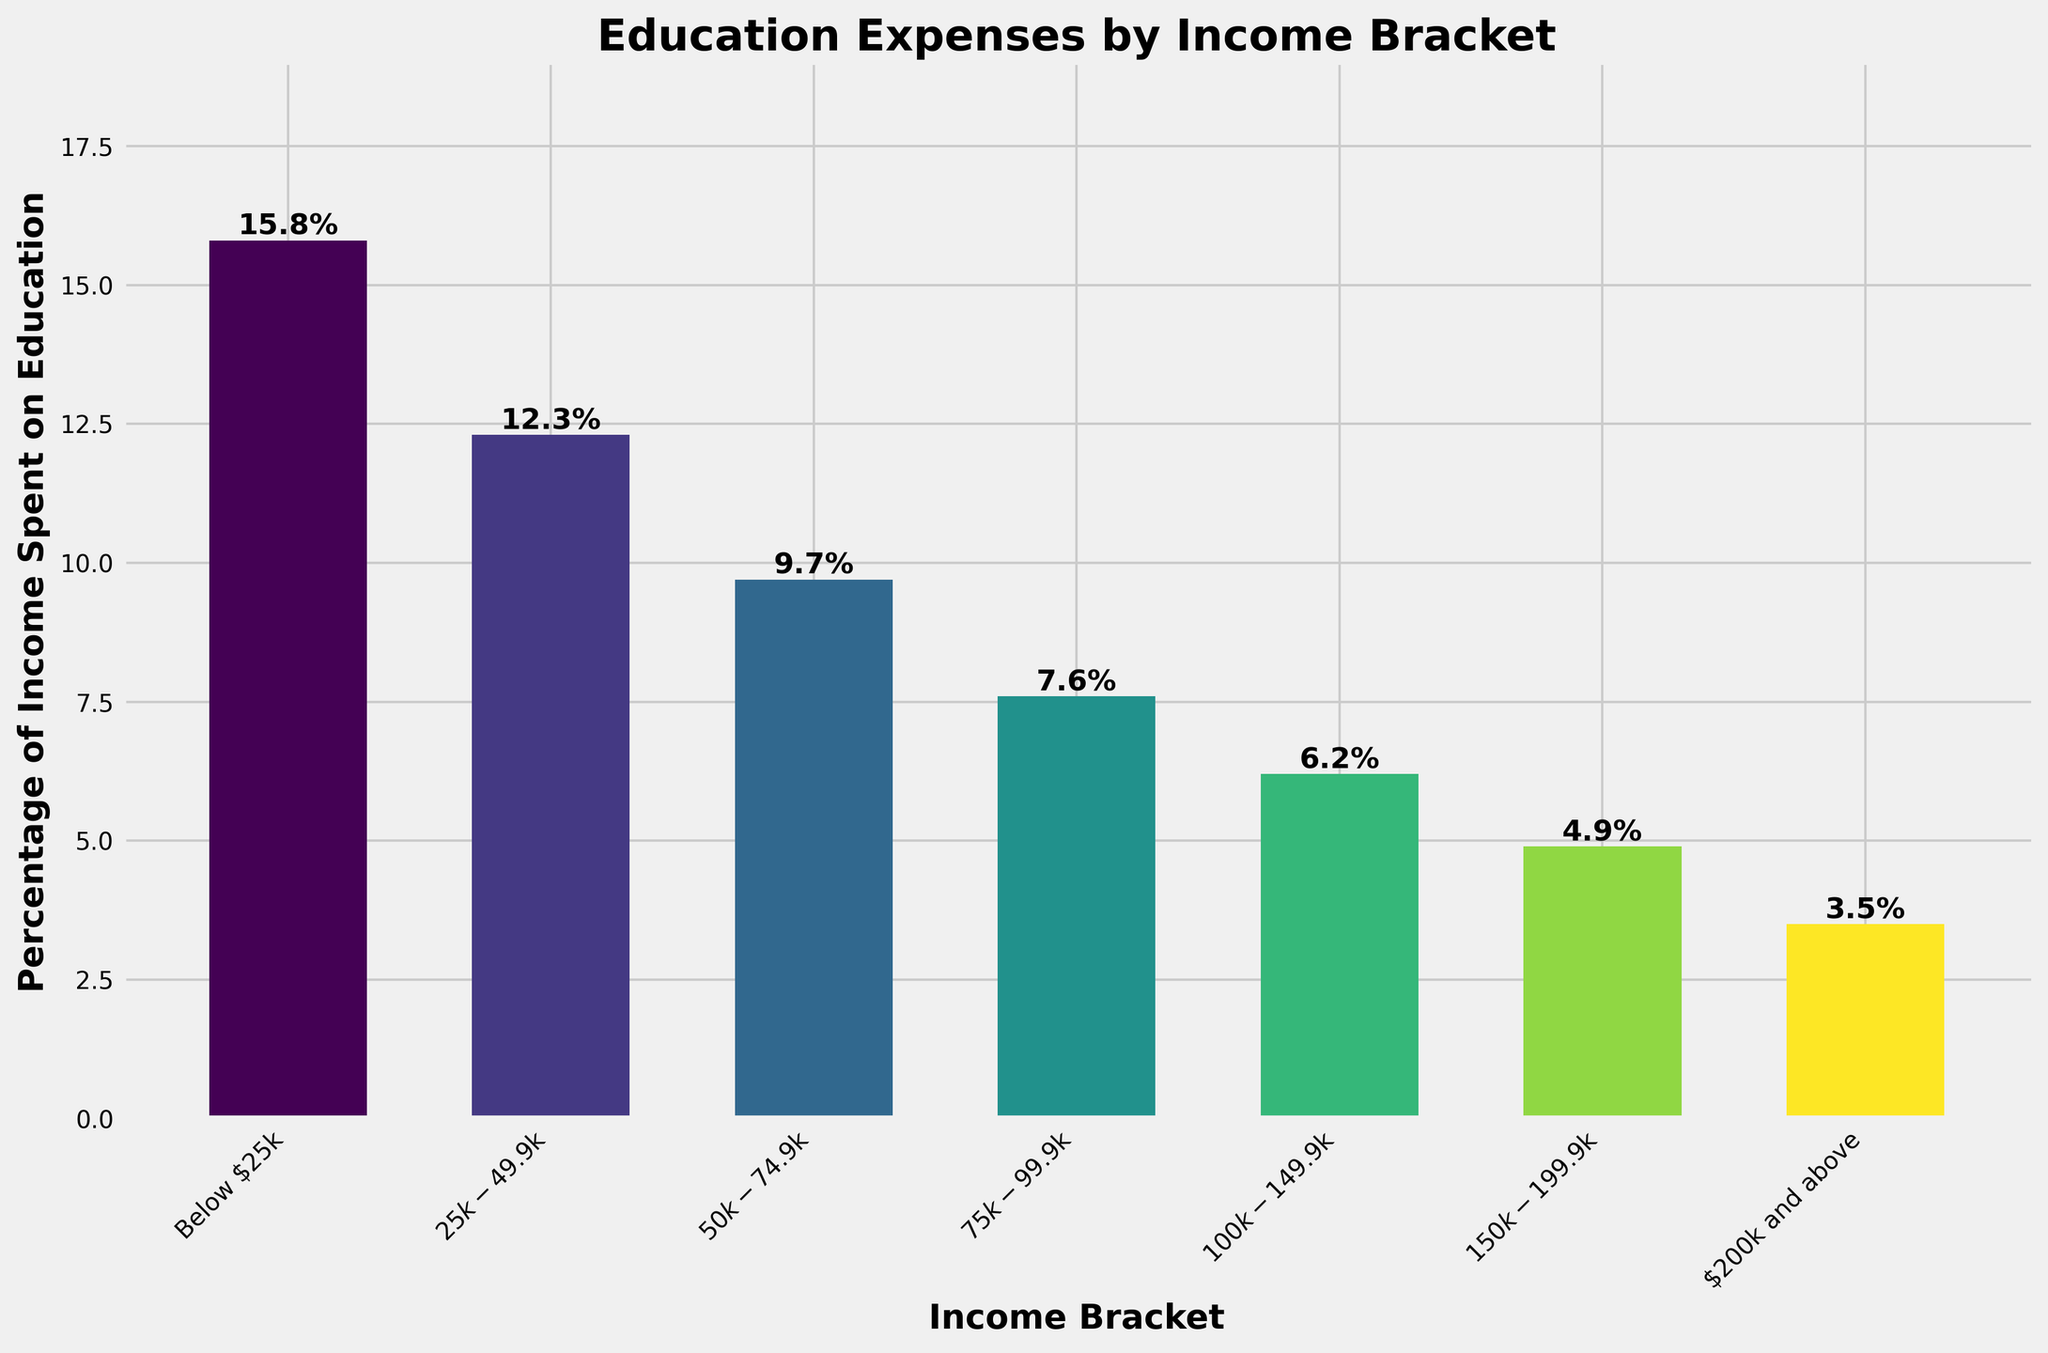What is the percentage of income spent on education by households in the $50k-$74.9k income bracket? The chart indicates that the height of the bar for the $50k-$74.9k income bracket represents the percentage of income spent on education. The label on the bar shows the exact percentage.
Answer: 9.7% Which income bracket spends the highest percentage of their income on education? The height of the bars on the chart indicates the percentage of income spent on education by each income bracket. The tallest bar corresponds to the income bracket that spends the highest percentage.
Answer: Below $25k Which income bracket spends the lowest percentage of their income on education? To find the income bracket that spends the lowest percentage, look for the shortest bar on the chart. The income bracket at the shortest bar's position is the answer.
Answer: $200k and above What is the average percentage of income spent on education across all income brackets? Add all the percentages listed for each income bracket and then divide by the number of income brackets to get the average. Calculation: (15.8 + 12.3 + 9.7 + 7.6 + 6.2 + 4.9 + 3.5) / 7 = 8.571428571 ≈ 8.6%
Answer: 8.6% By how much does the percentage of income spent on education decrease from the Below $25k bracket to the $75k-$99.9k bracket? Subtract the percentage of the $75k-$99.9k bracket from the percentage of the Below $25k bracket. Calculation: 15.8 - 7.6 = 8.2
Answer: 8.2% How does the percentage of income spent on education by households in the $100k-$149.9k bracket compare to the $25k-$49.9k bracket? Compare the heights of the bars representing the $100k-$149.9k and $25k-$49.9k brackets. The bar for $100k-$149.9k is lower than the bar for $25k-$49.9k. The exact percentages are 6.2% and 12.3%, respectively.
Answer: Lower If a household's income increases from $50k to $150k, by how much does the percentage of income spent on education decrease? Identify the percentages for the $50k-$74.9k and the $150k-$199.9k brackets and subtract the latter from the former. Calculation: 9.7 - 4.9 = 4.8
Answer: 4.8% Are households in the $150k-$199.9k bracket spending more or less than half the percentage of income on education compared to the Below $25k bracket? Calculate half of the percentage for Below $25k and compare it to the $150k-$199.9k bracket. Half of 15.8 is 7.9. Since 4.9 is less than 7.9, they spend less than half.
Answer: Less What is the combined percentage of income spent on education for households earning below $50k? Add the percentages of the Below $25k and $25k-$49.9k income brackets. Calculation: 15.8 + 12.3 = 28.1
Answer: 28.1 